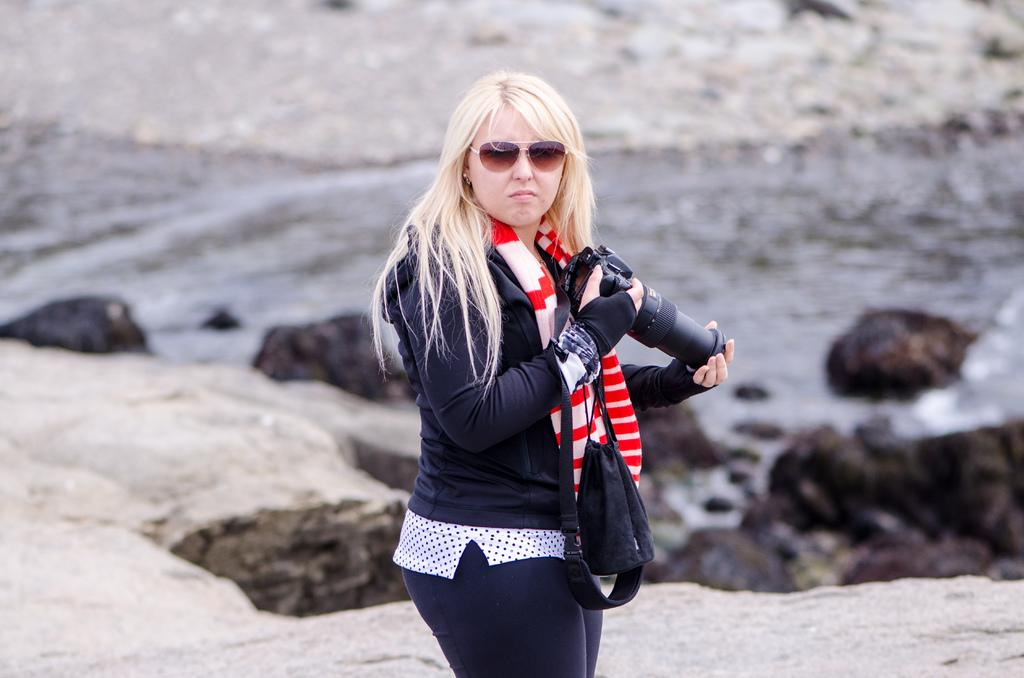Who is the main subject in the image? There is a lady in the image. What is the lady doing in the image? The lady is standing in the image. What is the lady holding in her hand? The lady is holding a camera in her hand. What can be seen behind the lady in the image? There is a river and rocks behind the lady in the image. What type of house can be seen in the image? There is no house present in the image. Is the lady using a plough in the image? There is no plough present in the image. 